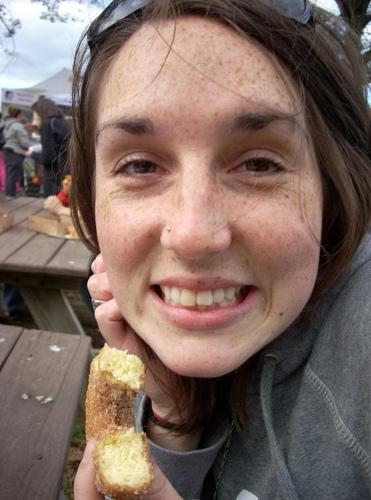What type of furniture is the girl sitting on?
Keep it brief. Picnic table. Is the doughnut plain or glazed?
Quick response, please. Plain. What is the woman wearing on her face?
Concise answer only. Nothing. What is the woman holding in her hands?
Write a very short answer. Donut. Does the girl have freckles?
Keep it brief. Yes. Is the woman licking her finger?
Give a very brief answer. No. What is in her mouth?
Give a very brief answer. Teeth. What is she eating?
Answer briefly. Donut. 